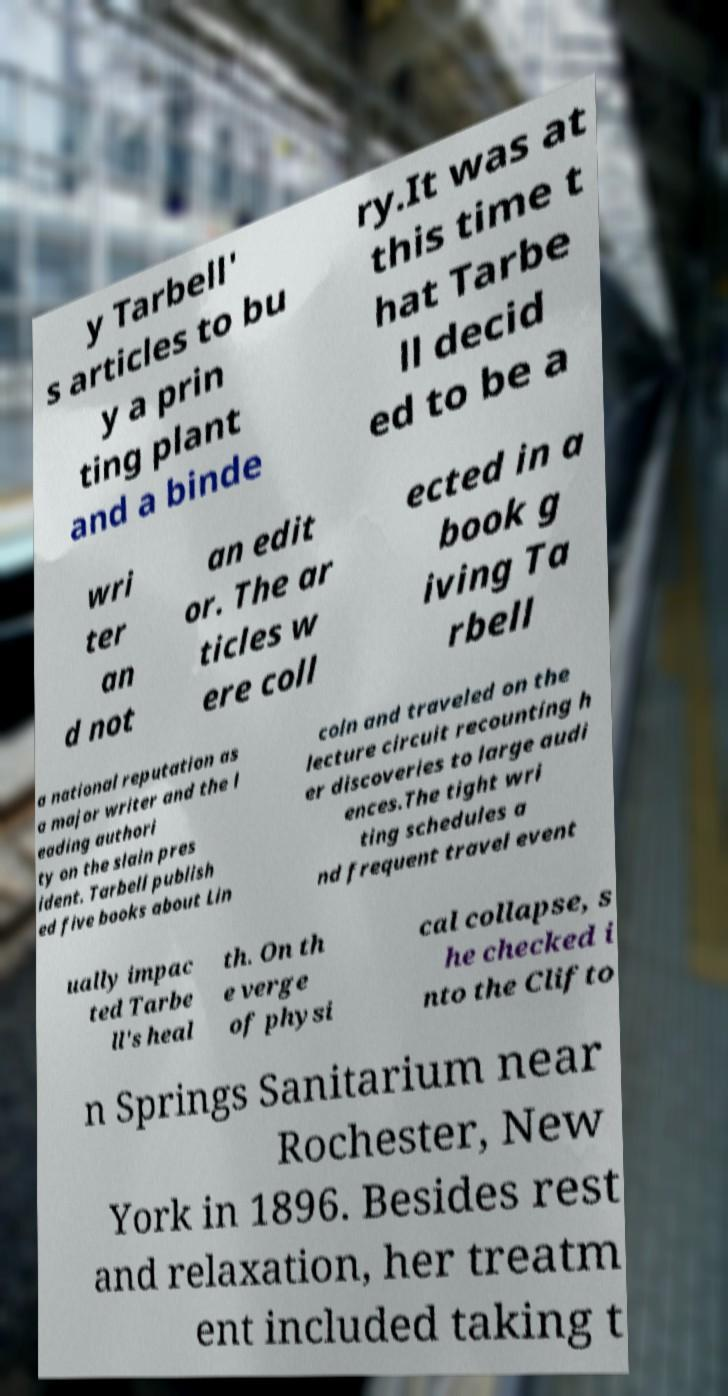For documentation purposes, I need the text within this image transcribed. Could you provide that? y Tarbell' s articles to bu y a prin ting plant and a binde ry.It was at this time t hat Tarbe ll decid ed to be a wri ter an d not an edit or. The ar ticles w ere coll ected in a book g iving Ta rbell a national reputation as a major writer and the l eading authori ty on the slain pres ident. Tarbell publish ed five books about Lin coln and traveled on the lecture circuit recounting h er discoveries to large audi ences.The tight wri ting schedules a nd frequent travel event ually impac ted Tarbe ll's heal th. On th e verge of physi cal collapse, s he checked i nto the Clifto n Springs Sanitarium near Rochester, New York in 1896. Besides rest and relaxation, her treatm ent included taking t 